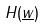<formula> <loc_0><loc_0><loc_500><loc_500>H ( \underline { w } )</formula> 